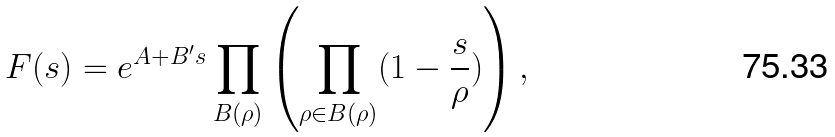<formula> <loc_0><loc_0><loc_500><loc_500>F ( s ) = e ^ { A + B ^ { \prime } s } \prod _ { B ( \rho ) } \left ( \prod _ { \rho \in B ( \rho ) } ( 1 - \frac { s } { \rho } ) \right ) ,</formula> 